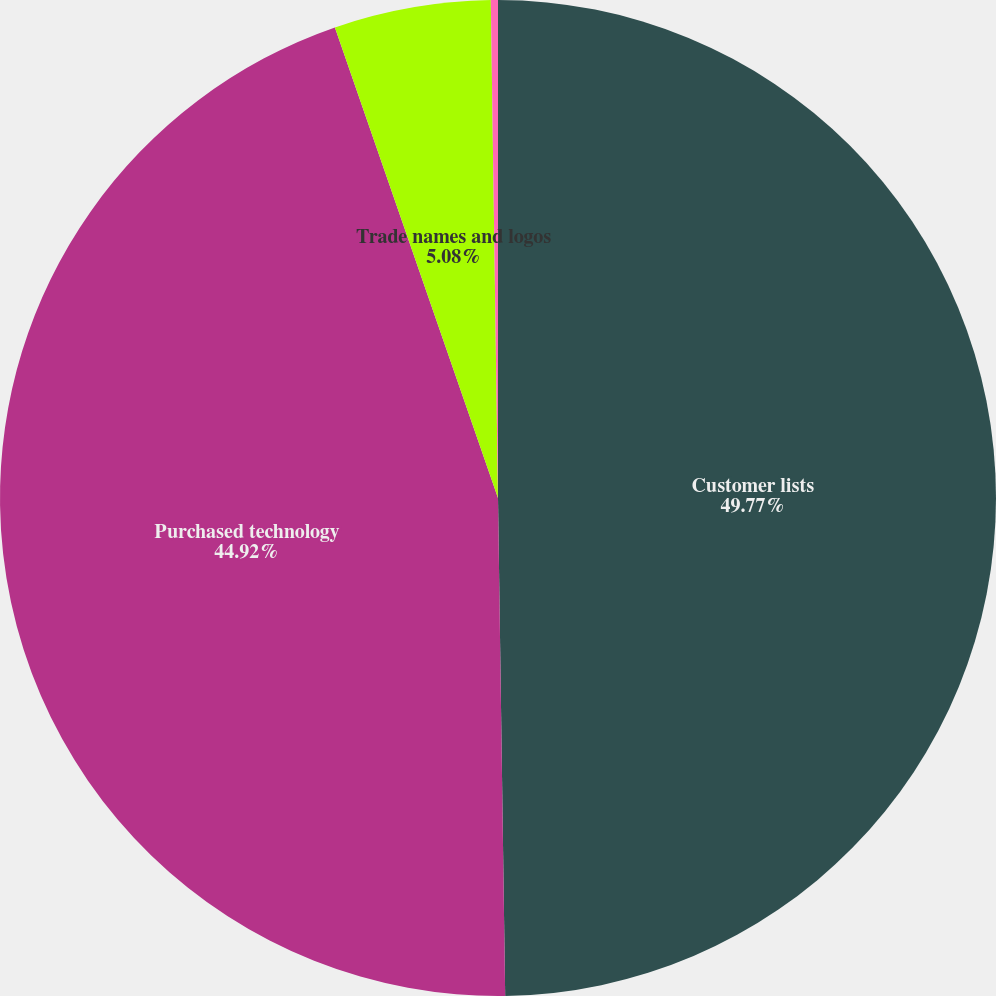Convert chart to OTSL. <chart><loc_0><loc_0><loc_500><loc_500><pie_chart><fcel>Customer lists<fcel>Purchased technology<fcel>Trade names and logos<fcel>Covenants not to compete<nl><fcel>49.77%<fcel>44.92%<fcel>5.08%<fcel>0.23%<nl></chart> 